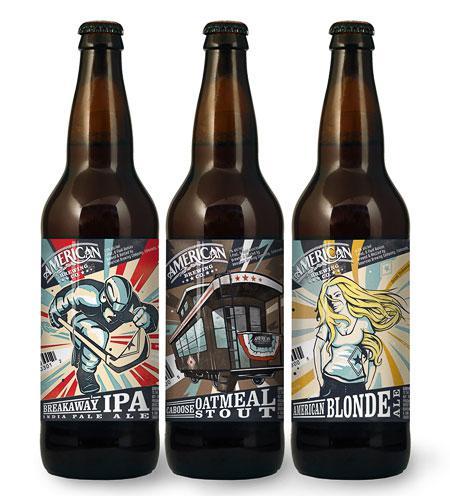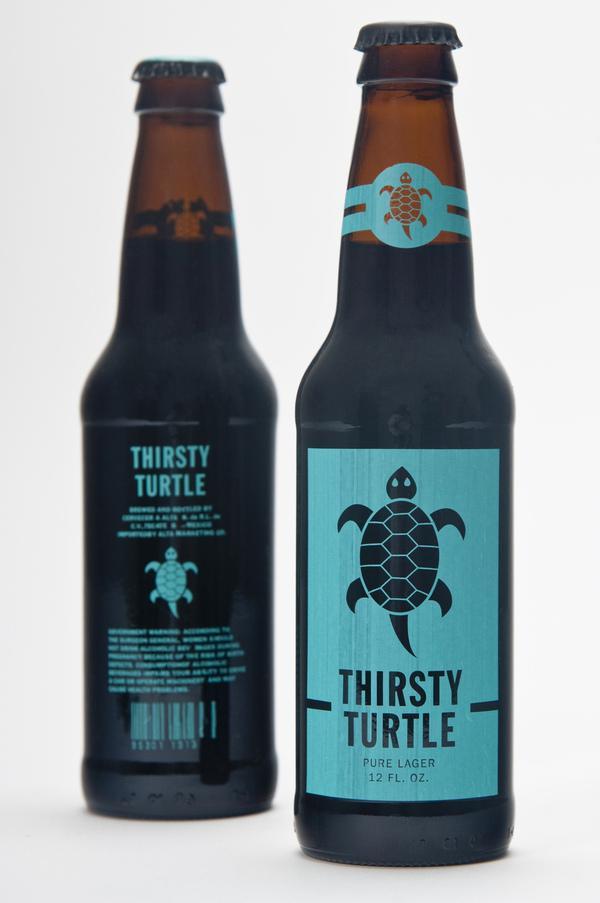The first image is the image on the left, the second image is the image on the right. For the images shown, is this caption "A total of five beer bottles are depicted." true? Answer yes or no. Yes. 